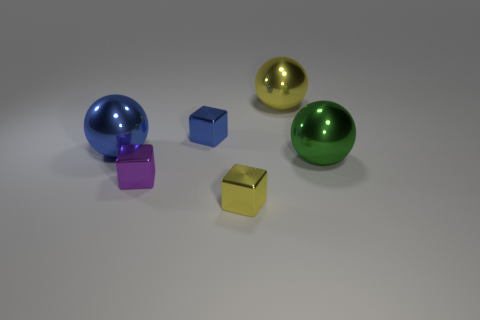Add 4 tiny purple metallic objects. How many objects exist? 10 Subtract 1 yellow cubes. How many objects are left? 5 Subtract all yellow metallic objects. Subtract all tiny blue cubes. How many objects are left? 3 Add 4 yellow blocks. How many yellow blocks are left? 5 Add 2 blue metal cubes. How many blue metal cubes exist? 3 